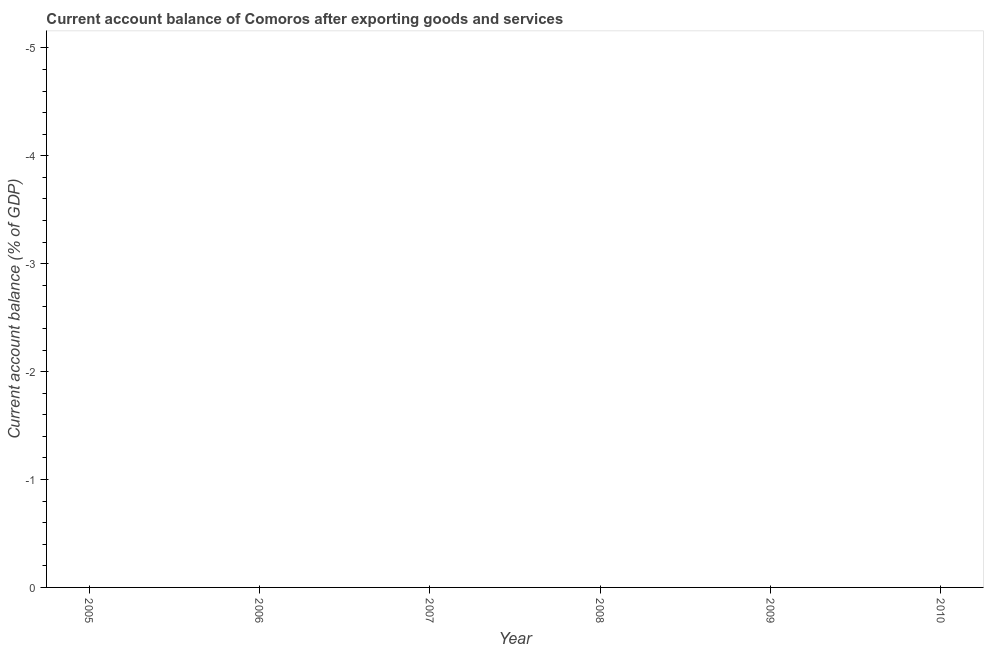What is the average current account balance per year?
Your answer should be compact. 0. What is the median current account balance?
Offer a very short reply. 0. In how many years, is the current account balance greater than the average current account balance taken over all years?
Your answer should be very brief. 0. How many dotlines are there?
Provide a succinct answer. 0. How many years are there in the graph?
Give a very brief answer. 6. What is the difference between two consecutive major ticks on the Y-axis?
Keep it short and to the point. 1. What is the title of the graph?
Keep it short and to the point. Current account balance of Comoros after exporting goods and services. What is the label or title of the X-axis?
Offer a terse response. Year. What is the label or title of the Y-axis?
Your answer should be very brief. Current account balance (% of GDP). What is the Current account balance (% of GDP) in 2006?
Ensure brevity in your answer.  0. What is the Current account balance (% of GDP) in 2007?
Give a very brief answer. 0. What is the Current account balance (% of GDP) in 2008?
Provide a succinct answer. 0. What is the Current account balance (% of GDP) in 2010?
Offer a terse response. 0. 